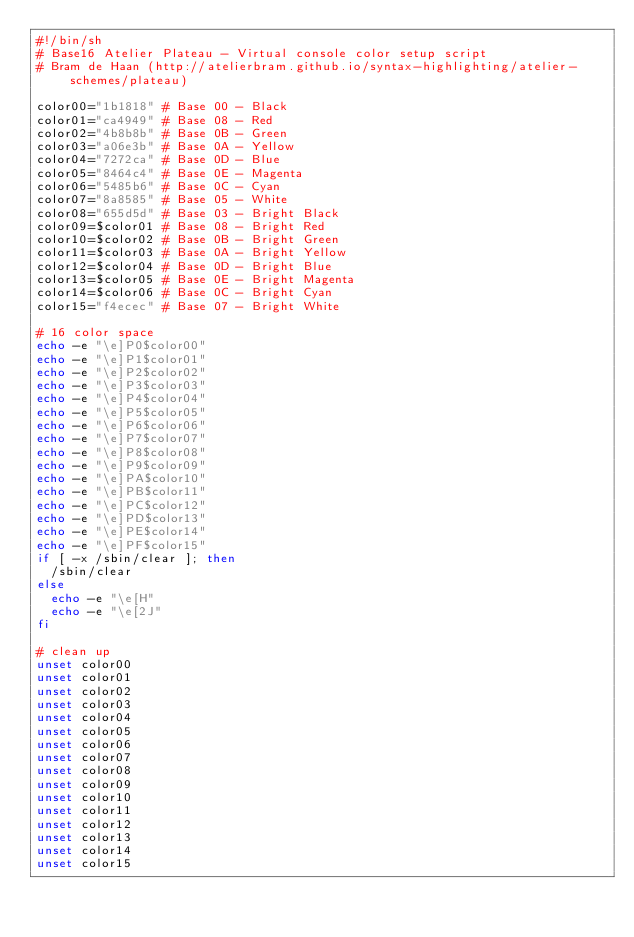Convert code to text. <code><loc_0><loc_0><loc_500><loc_500><_Bash_>#!/bin/sh
# Base16 Atelier Plateau - Virtual console color setup script
# Bram de Haan (http://atelierbram.github.io/syntax-highlighting/atelier-schemes/plateau)

color00="1b1818" # Base 00 - Black
color01="ca4949" # Base 08 - Red
color02="4b8b8b" # Base 0B - Green
color03="a06e3b" # Base 0A - Yellow
color04="7272ca" # Base 0D - Blue
color05="8464c4" # Base 0E - Magenta
color06="5485b6" # Base 0C - Cyan
color07="8a8585" # Base 05 - White
color08="655d5d" # Base 03 - Bright Black
color09=$color01 # Base 08 - Bright Red
color10=$color02 # Base 0B - Bright Green
color11=$color03 # Base 0A - Bright Yellow
color12=$color04 # Base 0D - Bright Blue
color13=$color05 # Base 0E - Bright Magenta
color14=$color06 # Base 0C - Bright Cyan
color15="f4ecec" # Base 07 - Bright White

# 16 color space
echo -e "\e]P0$color00"
echo -e "\e]P1$color01"
echo -e "\e]P2$color02"
echo -e "\e]P3$color03"
echo -e "\e]P4$color04"
echo -e "\e]P5$color05"
echo -e "\e]P6$color06"
echo -e "\e]P7$color07"
echo -e "\e]P8$color08"
echo -e "\e]P9$color09"
echo -e "\e]PA$color10"
echo -e "\e]PB$color11"
echo -e "\e]PC$color12"
echo -e "\e]PD$color13"
echo -e "\e]PE$color14"
echo -e "\e]PF$color15"
if [ -x /sbin/clear ]; then 
  /sbin/clear
else
  echo -e "\e[H"
  echo -e "\e[2J"
fi

# clean up
unset color00
unset color01
unset color02
unset color03
unset color04
unset color05
unset color06
unset color07
unset color08
unset color09
unset color10
unset color11
unset color12
unset color13
unset color14
unset color15
</code> 